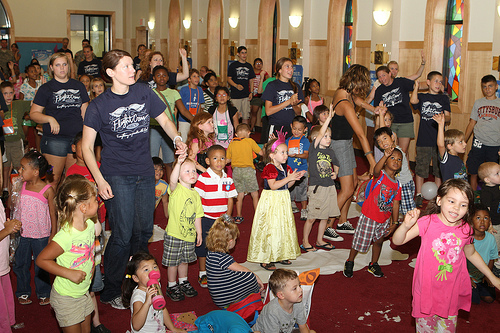<image>
Is there a child in the standing? Yes. The child is contained within or inside the standing, showing a containment relationship. 